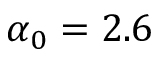<formula> <loc_0><loc_0><loc_500><loc_500>\alpha _ { 0 } = 2 . 6</formula> 